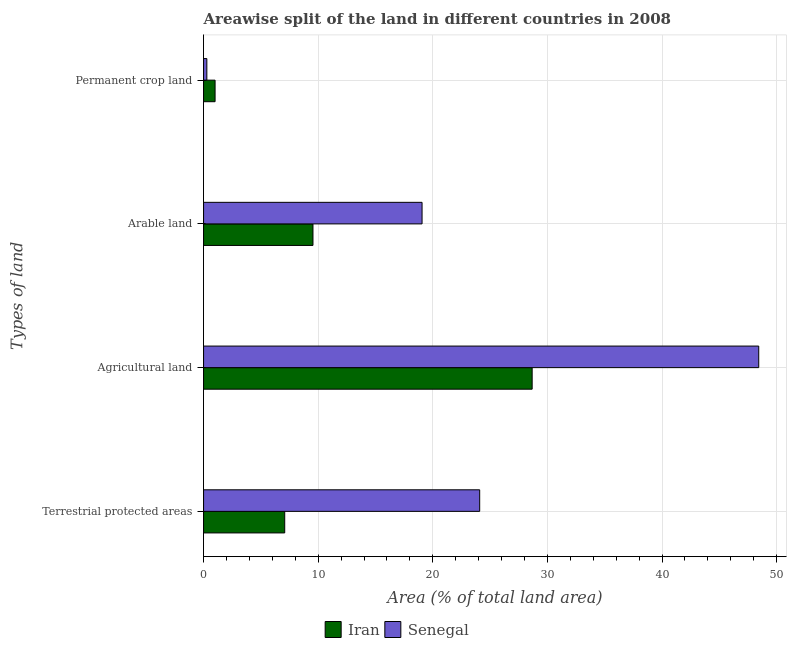How many groups of bars are there?
Provide a short and direct response. 4. Are the number of bars per tick equal to the number of legend labels?
Your response must be concise. Yes. Are the number of bars on each tick of the Y-axis equal?
Offer a terse response. Yes. How many bars are there on the 2nd tick from the top?
Your answer should be very brief. 2. What is the label of the 1st group of bars from the top?
Your response must be concise. Permanent crop land. What is the percentage of area under agricultural land in Iran?
Offer a terse response. 28.67. Across all countries, what is the maximum percentage of land under terrestrial protection?
Make the answer very short. 24.09. Across all countries, what is the minimum percentage of land under terrestrial protection?
Your response must be concise. 7.08. In which country was the percentage of area under permanent crop land maximum?
Your answer should be very brief. Iran. In which country was the percentage of area under agricultural land minimum?
Keep it short and to the point. Iran. What is the total percentage of area under permanent crop land in the graph?
Offer a terse response. 1.29. What is the difference between the percentage of area under arable land in Iran and that in Senegal?
Give a very brief answer. -9.52. What is the difference between the percentage of area under agricultural land in Iran and the percentage of area under arable land in Senegal?
Your response must be concise. 9.6. What is the average percentage of area under arable land per country?
Give a very brief answer. 14.3. What is the difference between the percentage of area under agricultural land and percentage of area under permanent crop land in Iran?
Your answer should be very brief. 27.66. In how many countries, is the percentage of land under terrestrial protection greater than 30 %?
Ensure brevity in your answer.  0. What is the ratio of the percentage of land under terrestrial protection in Iran to that in Senegal?
Make the answer very short. 0.29. Is the percentage of area under agricultural land in Senegal less than that in Iran?
Provide a short and direct response. No. What is the difference between the highest and the second highest percentage of land under terrestrial protection?
Your response must be concise. 17.01. What is the difference between the highest and the lowest percentage of area under agricultural land?
Provide a succinct answer. 19.77. In how many countries, is the percentage of area under arable land greater than the average percentage of area under arable land taken over all countries?
Make the answer very short. 1. Is the sum of the percentage of area under agricultural land in Senegal and Iran greater than the maximum percentage of area under permanent crop land across all countries?
Give a very brief answer. Yes. What does the 1st bar from the top in Terrestrial protected areas represents?
Keep it short and to the point. Senegal. What does the 2nd bar from the bottom in Terrestrial protected areas represents?
Your answer should be compact. Senegal. How many bars are there?
Offer a terse response. 8. Are all the bars in the graph horizontal?
Ensure brevity in your answer.  Yes. How many countries are there in the graph?
Your answer should be very brief. 2. Does the graph contain any zero values?
Make the answer very short. No. How are the legend labels stacked?
Provide a succinct answer. Horizontal. What is the title of the graph?
Give a very brief answer. Areawise split of the land in different countries in 2008. Does "Malawi" appear as one of the legend labels in the graph?
Your answer should be compact. No. What is the label or title of the X-axis?
Offer a very short reply. Area (% of total land area). What is the label or title of the Y-axis?
Offer a very short reply. Types of land. What is the Area (% of total land area) of Iran in Terrestrial protected areas?
Your answer should be very brief. 7.08. What is the Area (% of total land area) in Senegal in Terrestrial protected areas?
Give a very brief answer. 24.09. What is the Area (% of total land area) of Iran in Agricultural land?
Ensure brevity in your answer.  28.67. What is the Area (% of total land area) of Senegal in Agricultural land?
Offer a very short reply. 48.43. What is the Area (% of total land area) in Iran in Arable land?
Offer a terse response. 9.55. What is the Area (% of total land area) in Senegal in Arable land?
Provide a succinct answer. 19.06. What is the Area (% of total land area) of Iran in Permanent crop land?
Give a very brief answer. 1.01. What is the Area (% of total land area) in Senegal in Permanent crop land?
Offer a very short reply. 0.29. Across all Types of land, what is the maximum Area (% of total land area) in Iran?
Ensure brevity in your answer.  28.67. Across all Types of land, what is the maximum Area (% of total land area) of Senegal?
Offer a very short reply. 48.43. Across all Types of land, what is the minimum Area (% of total land area) of Iran?
Give a very brief answer. 1.01. Across all Types of land, what is the minimum Area (% of total land area) of Senegal?
Your response must be concise. 0.29. What is the total Area (% of total land area) in Iran in the graph?
Ensure brevity in your answer.  46.3. What is the total Area (% of total land area) of Senegal in the graph?
Give a very brief answer. 91.87. What is the difference between the Area (% of total land area) of Iran in Terrestrial protected areas and that in Agricultural land?
Keep it short and to the point. -21.59. What is the difference between the Area (% of total land area) in Senegal in Terrestrial protected areas and that in Agricultural land?
Offer a very short reply. -24.34. What is the difference between the Area (% of total land area) of Iran in Terrestrial protected areas and that in Arable land?
Provide a succinct answer. -2.47. What is the difference between the Area (% of total land area) of Senegal in Terrestrial protected areas and that in Arable land?
Your answer should be compact. 5.03. What is the difference between the Area (% of total land area) of Iran in Terrestrial protected areas and that in Permanent crop land?
Give a very brief answer. 6.07. What is the difference between the Area (% of total land area) of Senegal in Terrestrial protected areas and that in Permanent crop land?
Your response must be concise. 23.8. What is the difference between the Area (% of total land area) in Iran in Agricultural land and that in Arable land?
Offer a terse response. 19.12. What is the difference between the Area (% of total land area) of Senegal in Agricultural land and that in Arable land?
Ensure brevity in your answer.  29.37. What is the difference between the Area (% of total land area) of Iran in Agricultural land and that in Permanent crop land?
Your response must be concise. 27.66. What is the difference between the Area (% of total land area) in Senegal in Agricultural land and that in Permanent crop land?
Your response must be concise. 48.15. What is the difference between the Area (% of total land area) of Iran in Arable land and that in Permanent crop land?
Provide a succinct answer. 8.54. What is the difference between the Area (% of total land area) of Senegal in Arable land and that in Permanent crop land?
Your answer should be compact. 18.78. What is the difference between the Area (% of total land area) of Iran in Terrestrial protected areas and the Area (% of total land area) of Senegal in Agricultural land?
Your response must be concise. -41.35. What is the difference between the Area (% of total land area) of Iran in Terrestrial protected areas and the Area (% of total land area) of Senegal in Arable land?
Your answer should be compact. -11.98. What is the difference between the Area (% of total land area) in Iran in Terrestrial protected areas and the Area (% of total land area) in Senegal in Permanent crop land?
Ensure brevity in your answer.  6.79. What is the difference between the Area (% of total land area) in Iran in Agricultural land and the Area (% of total land area) in Senegal in Arable land?
Give a very brief answer. 9.6. What is the difference between the Area (% of total land area) of Iran in Agricultural land and the Area (% of total land area) of Senegal in Permanent crop land?
Make the answer very short. 28.38. What is the difference between the Area (% of total land area) of Iran in Arable land and the Area (% of total land area) of Senegal in Permanent crop land?
Offer a very short reply. 9.26. What is the average Area (% of total land area) in Iran per Types of land?
Your answer should be compact. 11.57. What is the average Area (% of total land area) in Senegal per Types of land?
Provide a succinct answer. 22.97. What is the difference between the Area (% of total land area) in Iran and Area (% of total land area) in Senegal in Terrestrial protected areas?
Make the answer very short. -17.01. What is the difference between the Area (% of total land area) in Iran and Area (% of total land area) in Senegal in Agricultural land?
Keep it short and to the point. -19.77. What is the difference between the Area (% of total land area) of Iran and Area (% of total land area) of Senegal in Arable land?
Your answer should be compact. -9.52. What is the difference between the Area (% of total land area) of Iran and Area (% of total land area) of Senegal in Permanent crop land?
Provide a short and direct response. 0.72. What is the ratio of the Area (% of total land area) of Iran in Terrestrial protected areas to that in Agricultural land?
Your answer should be very brief. 0.25. What is the ratio of the Area (% of total land area) of Senegal in Terrestrial protected areas to that in Agricultural land?
Keep it short and to the point. 0.5. What is the ratio of the Area (% of total land area) of Iran in Terrestrial protected areas to that in Arable land?
Your answer should be compact. 0.74. What is the ratio of the Area (% of total land area) of Senegal in Terrestrial protected areas to that in Arable land?
Provide a short and direct response. 1.26. What is the ratio of the Area (% of total land area) of Iran in Terrestrial protected areas to that in Permanent crop land?
Your answer should be very brief. 7.04. What is the ratio of the Area (% of total land area) of Senegal in Terrestrial protected areas to that in Permanent crop land?
Your answer should be very brief. 84.32. What is the ratio of the Area (% of total land area) in Iran in Agricultural land to that in Arable land?
Offer a terse response. 3. What is the ratio of the Area (% of total land area) in Senegal in Agricultural land to that in Arable land?
Your answer should be compact. 2.54. What is the ratio of the Area (% of total land area) of Iran in Agricultural land to that in Permanent crop land?
Provide a succinct answer. 28.52. What is the ratio of the Area (% of total land area) in Senegal in Agricultural land to that in Permanent crop land?
Offer a terse response. 169.55. What is the ratio of the Area (% of total land area) of Iran in Arable land to that in Permanent crop land?
Ensure brevity in your answer.  9.5. What is the ratio of the Area (% of total land area) of Senegal in Arable land to that in Permanent crop land?
Provide a short and direct response. 66.73. What is the difference between the highest and the second highest Area (% of total land area) in Iran?
Offer a terse response. 19.12. What is the difference between the highest and the second highest Area (% of total land area) of Senegal?
Make the answer very short. 24.34. What is the difference between the highest and the lowest Area (% of total land area) in Iran?
Offer a very short reply. 27.66. What is the difference between the highest and the lowest Area (% of total land area) of Senegal?
Your answer should be compact. 48.15. 